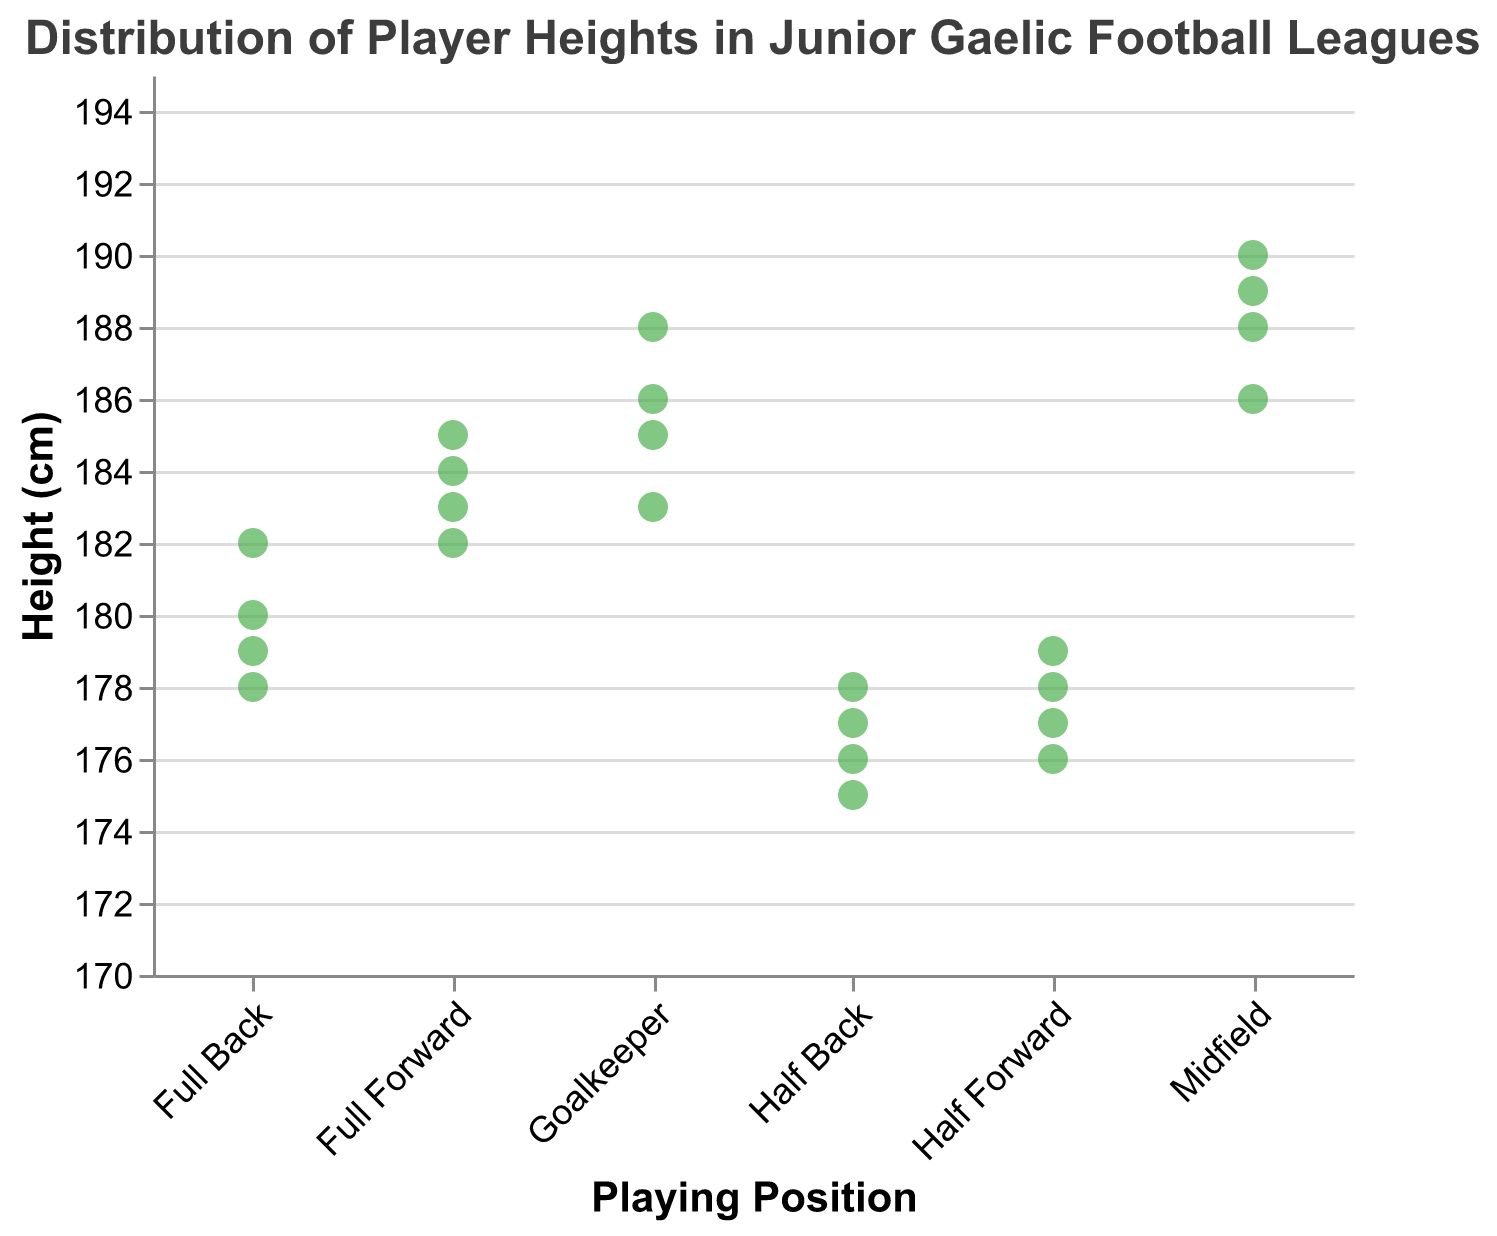1. What's the title of the plot? The title is shown at the top of the strip plot. It states "Distribution of Player Heights in Junior Gaelic Football Leagues".
Answer: "Distribution of Player Heights in Junior Gaelic Football Leagues" 2. What is the height range used on the y-axis? The height range on the y-axis is displayed from 170 cm to 195 cm, as indicated by the domain set in the y-axis properties.
Answer: 170 cm to 195 cm 3. Which playing position has the tallest players on average? To find the tallest players on average, observe the clusters of heights for each position. Midfield has heights consistently around 188-190 cm, which makes it clear that midfielders are the tallest on average.
Answer: Midfield 4. What is the height of the shortest Half Back player? Look at the heights for Half Back. The lowest point is at 175 cm, which is the height of the shortest Half Back.
Answer: 175 cm 5. How many data points represent Full Forward players? Count the number of data points under the Full Forward category. There are 4 data points.
Answer: 4 6. Are Goalkeepers generally taller than Half Forwards? Compare the range of heights for Goalkeepers (183-188 cm) with that for Half Forwards (176-179 cm). The Goalkeepers have higher height values overall indicating they are generally taller.
Answer: Yes 7. What is the median height of Full Backs? The Full Backs have heights of 180, 178, 182, and 179 cm. When ordered (178, 179, 180, 182), the median is between 179 and 180, which averages to 179.5 cm.
Answer: 179.5 cm 8. Which position has the most variation in player heights? Calculate the range for each position (max height - min height). For Goalkeepers (188-183=5 cm), Full Back (182-178=4 cm), Half Back (178-175=3 cm), Midfield (190-186=4 cm), and Half Forward (179-176=3 cm). Goalkeepers have the highest variation of 5 cm.
Answer: Goalkeepers 9. Do any positions share the same maximum player height? Identify the maximum height for each position. Goalkeepers: 188 cm, Full Back: 182 cm, Half Back: 178 cm, Midfield: 190 cm, Half Forward: 179 cm, Full Forward: 185 cm. No two positions share the same maximum height.
Answer: No 10. Which position has the smallest height range? Compute the height range for each position: Goalkeepers (5 cm), Full Back (4 cm), Half Back (3 cm), Midfield (4 cm), Half Forward (3 cm), Full Forward (3 cm). Half Back, Half Forward, and Full Forward all have the smallest range of 3 cm.
Answer: Half Back, Half Forward, Full Forward 